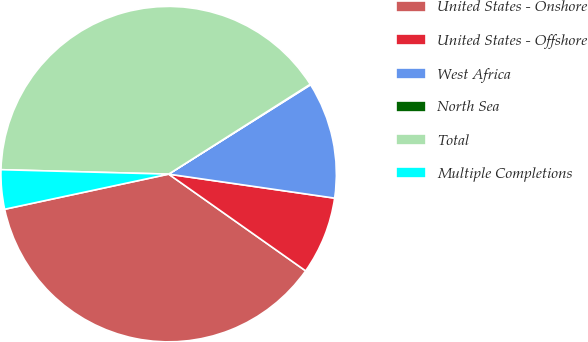Convert chart to OTSL. <chart><loc_0><loc_0><loc_500><loc_500><pie_chart><fcel>United States - Onshore<fcel>United States - Offshore<fcel>West Africa<fcel>North Sea<fcel>Total<fcel>Multiple Completions<nl><fcel>36.86%<fcel>7.5%<fcel>11.23%<fcel>0.06%<fcel>40.58%<fcel>3.78%<nl></chart> 